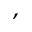Convert formula to latex. <formula><loc_0><loc_0><loc_500><loc_500>^ { , }</formula> 